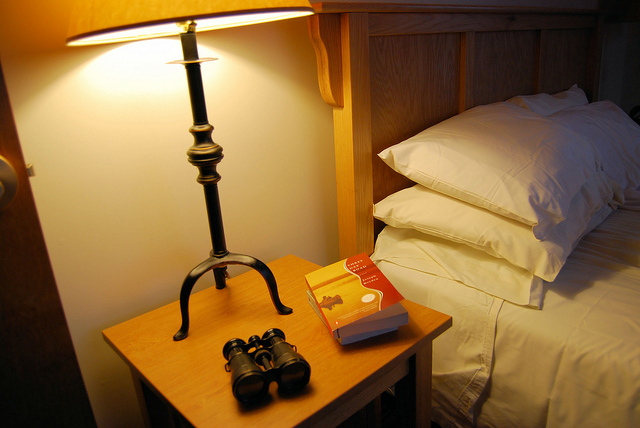How many pillows are there? There are four pillows neatly stacked on the bed, providing plenty of comfort for a good night's rest. 